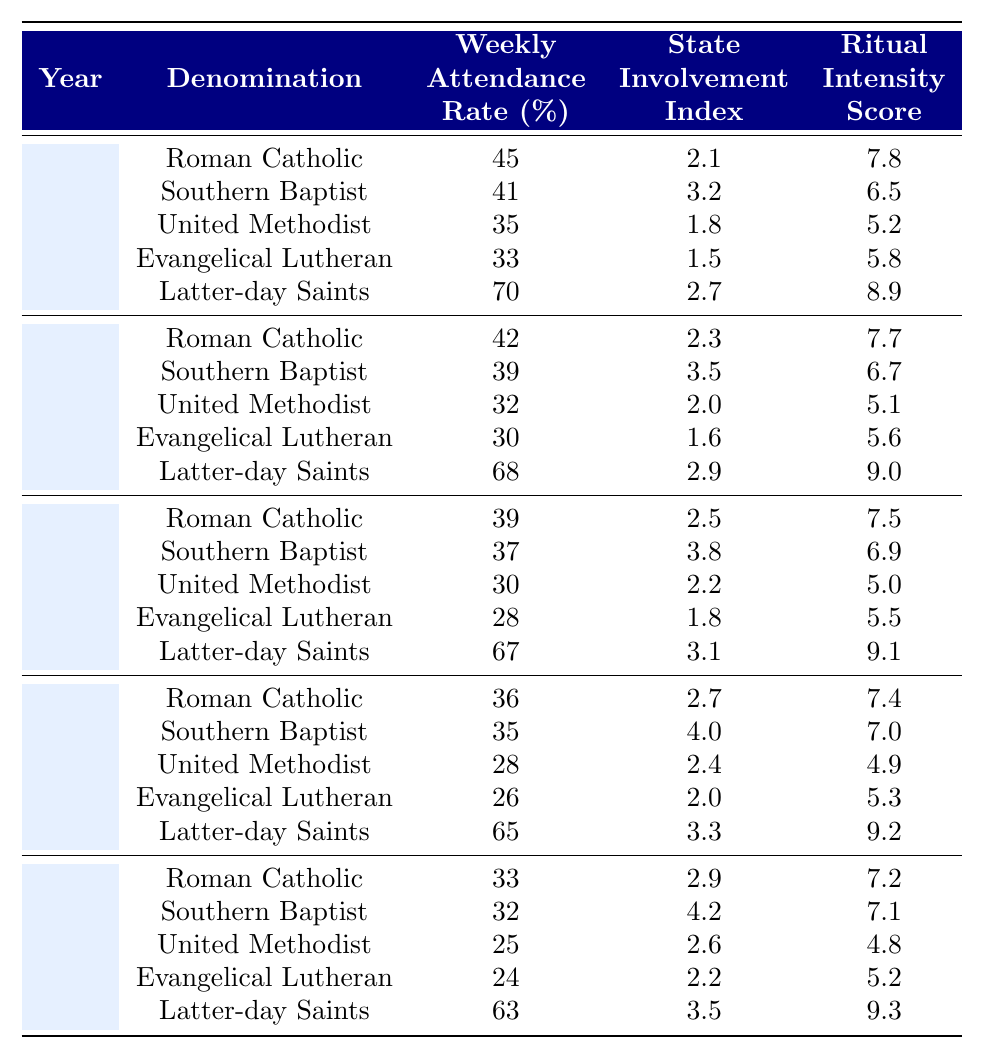What was the weekly attendance rate for Latter-day Saints in 2010? In the table, under the year 2010 and for the denomination Latter-day Saints, the weekly attendance rate is listed as 67%.
Answer: 67% What is the difference in weekly attendance rates between Roman Catholics and Southern Baptists in 2005? For 2005, Roman Catholics had a weekly attendance rate of 42% and Southern Baptists had 39%. The difference is 42 - 39 = 3%.
Answer: 3% What is the average weekly attendance rate for Evangelical Lutherans from 2000 to 2020? The attendance rates for Evangelical Lutherans are: 33% (2000), 30% (2005), 28% (2010), 26% (2015), 24% (2020). Totaling these gives 33 + 30 + 28 + 26 + 24 = 141%. Dividing by the 5 years gives an average of 141/5 = 28.2%.
Answer: 28.2% Did the weekly attendance rate for United Methodists increase from 2000 to 2020? In 2000, the weekly attendance rate for United Methodists was 35%, and in 2020 it dropped to 25%. Therefore, there was a decrease, not an increase.
Answer: No Which denomination had the highest weekly attendance rate in 2005 and what was the rate? In 2005, Latter-day Saints had the highest attendance rate at 68%. Comparing all denominations for that year confirms this.
Answer: 68% What is the overall trend in the weekly attendance rates for Roman Catholics from 2000 to 2020? The attendance rates for Roman Catholics are: 45% (2000), 42% (2005), 39% (2010), 36% (2015), and 33% (2020). The values show a steady decrease over the years.
Answer: Decreasing What was the highest State Involvement Index recorded across all denominations in 2015? For 2015, the State Involvement Index values are: Roman Catholic - 2.7, Southern Baptist - 4.0, United Methodist - 2.4, Evangelical Lutheran - 2.0, Latter-day Saints - 3.3. The highest value is 4.0 for Southern Baptists.
Answer: 4.0 Which year saw the lowest attendance for United Methodists and what was that rate? United Methodists had a weekly attendance rate of 25% in 2020, which is the lowest compared to 35% (2000), 32% (2005), 30% (2010), and 28% (2015).
Answer: 25% What denomination maintained the highest rate of attendance throughout the 20 years and what was that rate in 2020? Latter-day Saints consistently had the highest attendance rate. In 2020, their rate was 63%, which is higher than all other denominations for that year.
Answer: 63% Was there a correlation between State Involvement Index and Ritual Intensity Score for Latter-day Saints over the years? For Latter-day Saints, the State Involvement Index and Ritual Intensity Scores are as follows: (2000: 2.7, 8.9), (2005: 2.9, 9.0), (2010: 3.1, 9.1), (2015: 3.3, 9.2), (2020: 3.5, 9.3). Both values tend to increase together, suggesting a positive correlation.
Answer: Yes 